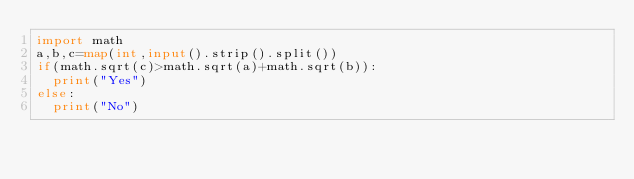<code> <loc_0><loc_0><loc_500><loc_500><_Python_>import math
a,b,c=map(int,input().strip().split())
if(math.sqrt(c)>math.sqrt(a)+math.sqrt(b)):
  print("Yes")
else:
  print("No")</code> 